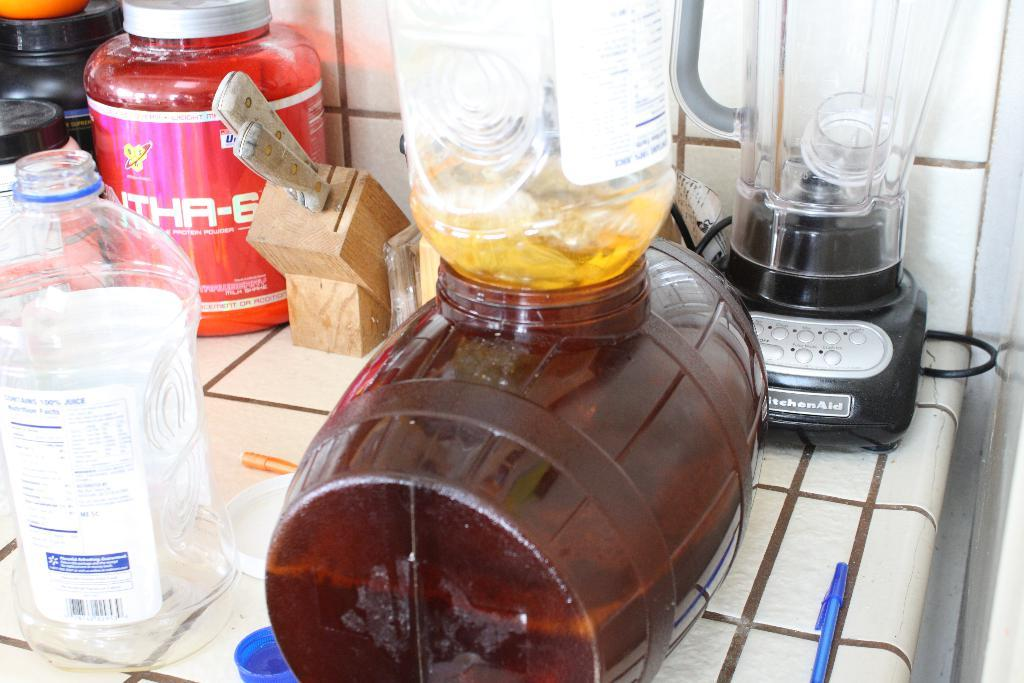<image>
Relay a brief, clear account of the picture shown. A Kitchen Aid blender on the counter with lots of other kitchen stuff. 